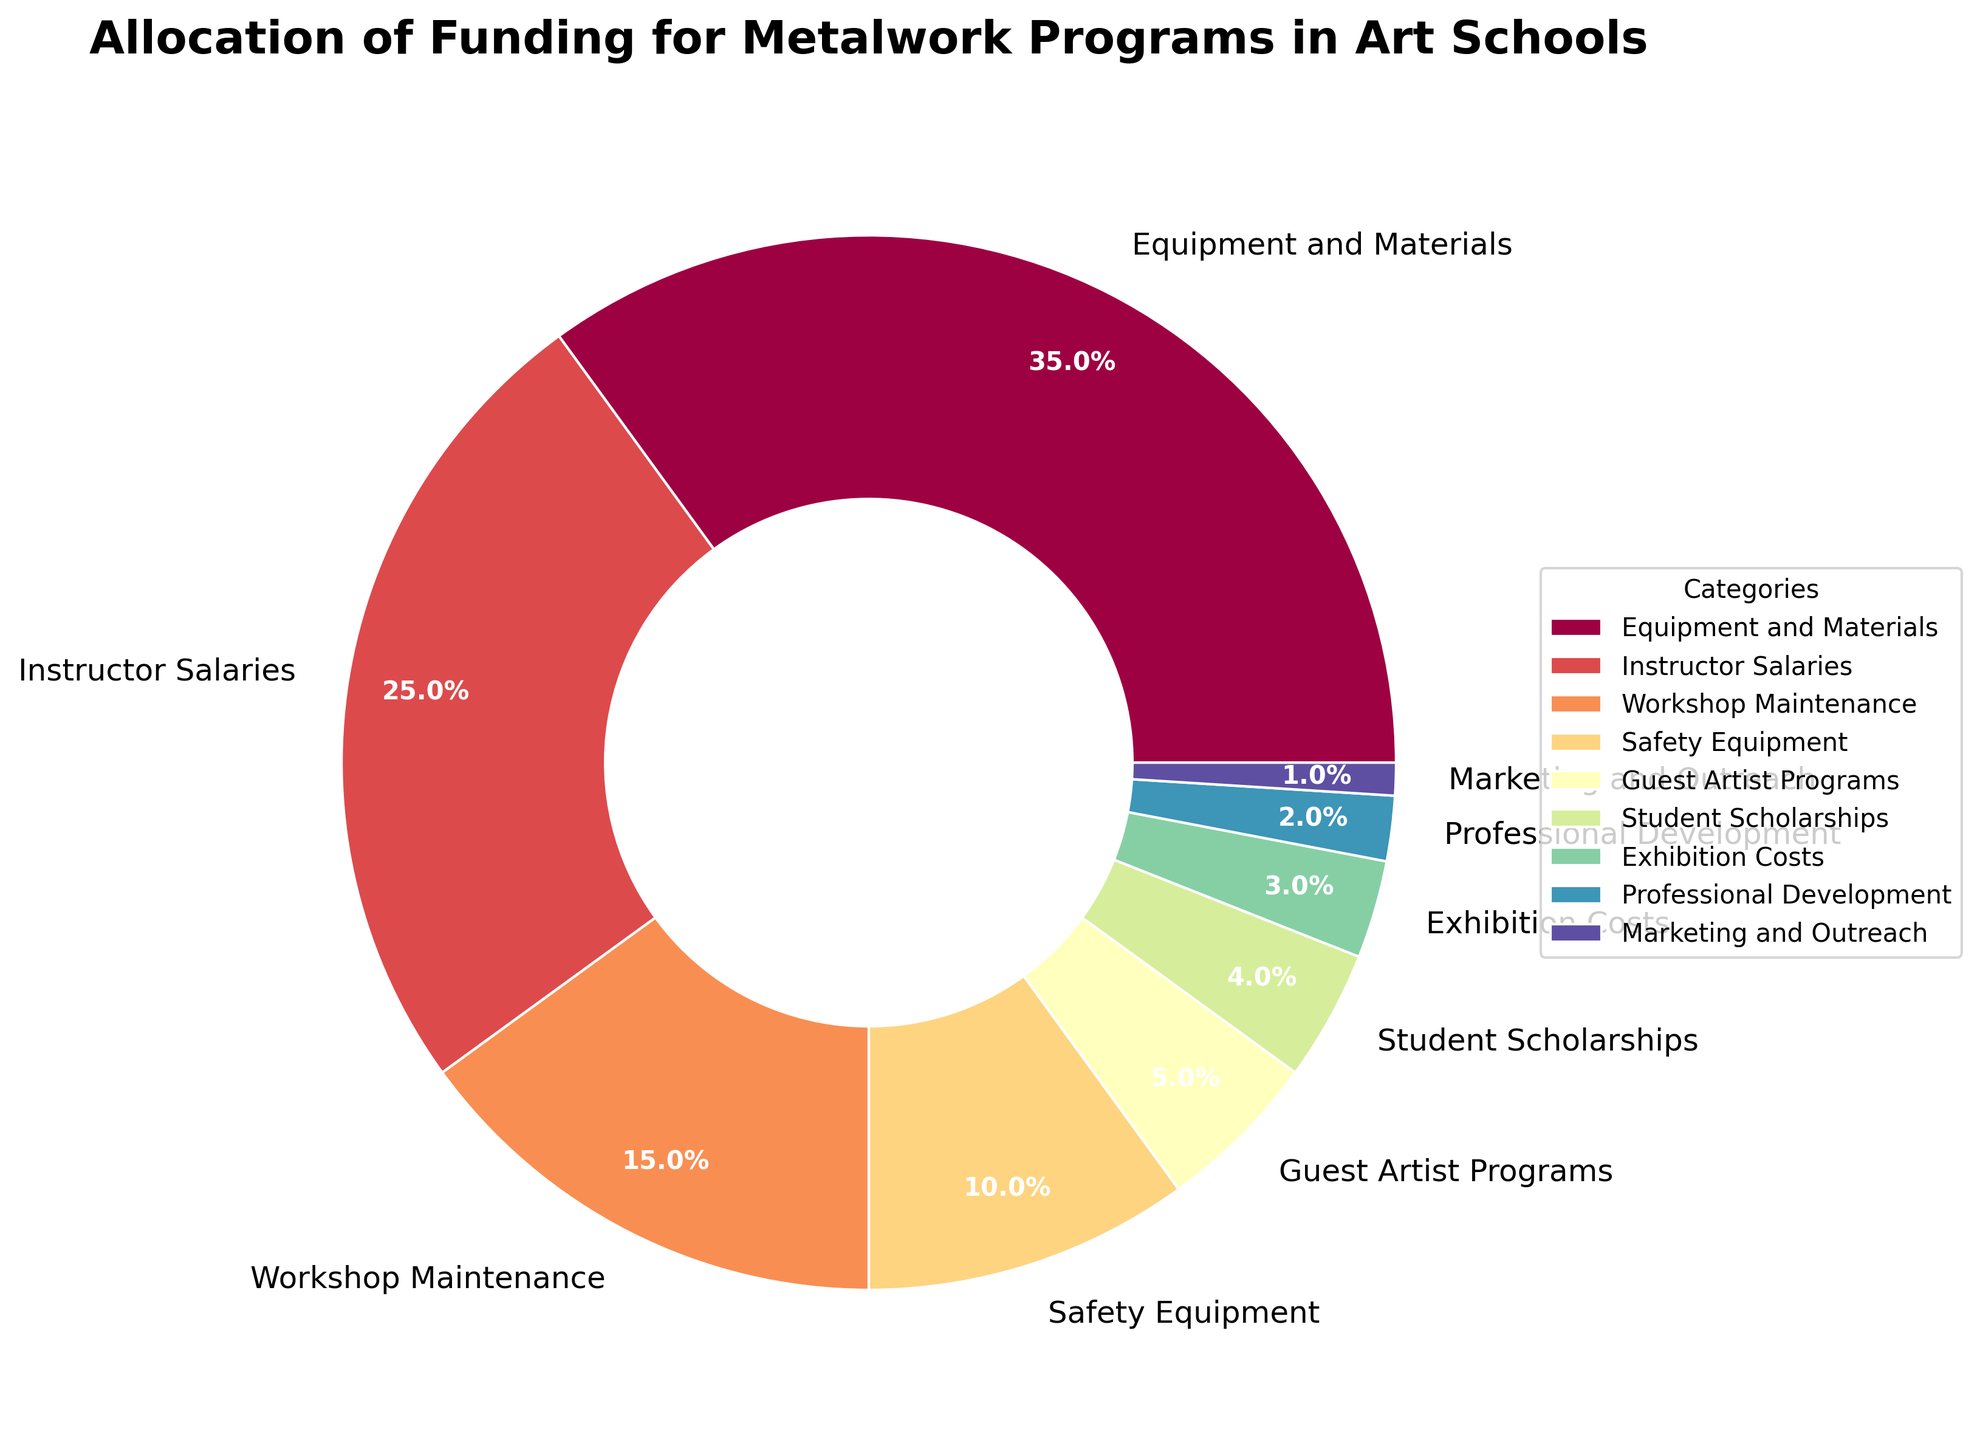What percentage of the funding goes to Instructor Salaries? Locate the section labeled "Instructor Salaries" on the pie chart and read the percentage written on it. The label shows 25%.
Answer: 25% What is the sum of the percentages allocated to Equipment and Materials, and Student Scholarships? Locate the sections labeled "Equipment and Materials" and "Student Scholarships" on the pie chart. Equipment and Materials has 35%, and Student Scholarships has 4%. Adding these, 35% + 4% = 39%.
Answer: 39% Which category has the smallest allocation of funding? Observe the pie chart and find the segment with the smallest portion. The label reads "Marketing and Outreach" which has 1%.
Answer: Marketing and Outreach How does the allocation for Workshop Maintenance compare to Safety Equipment? Locate the "Workshop Maintenance" segment with 15% and the "Safety Equipment" segment with 10% on the pie chart. Workshop Maintenance (15%) is larger by 5% than Safety Equipment (10%).
Answer: Workshop Maintenance is larger What is the combined percentage for Guest Artist Programs and Exhibition Costs? Find the segments labeled "Guest Artist Programs" and "Exhibition Costs" which have 5% and 3% respectively. Add 5% + 3% = 8%.
Answer: 8% If funding for Professional Development were doubled, what would its new percentage be? Professional Development currently has 2%. Doubling it would mean 2% x 2 = 4%.
Answer: 4% Which categories account for more than 25% of the funding individually? Check the pie chart for segments with percentages greater than 25%. Only "Equipment and Materials" has 35%, which is above 25%.
Answer: Equipment and Materials Is the total percentage allocation for all categories related to student benefits (Student Scholarships and Guest Artist Programs) greater than that of Equipment and Materials? Student Scholarships have 4% and Guest Artist Programs have 5%. Combined, it's 4% + 5% = 9%. Equipment and Materials is 35%. 9% is not greater than 35%.
Answer: No What is the difference between the percentages allocated to Instructor Salaries and Workshop Maintenance? Instructor Salaries are 25%, and Workshop Maintenance is 15%. Subtract 15% from 25%, which equals 10%.
Answer: 10% 